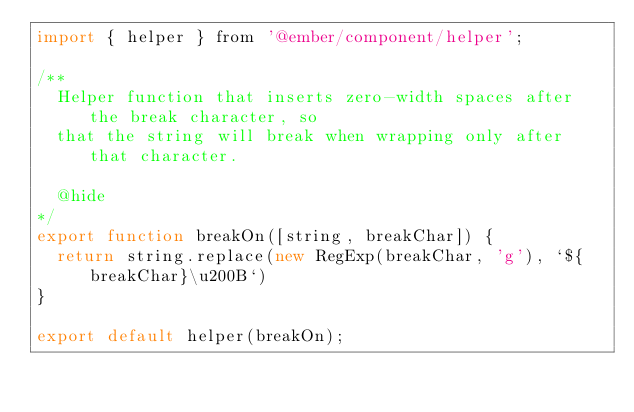<code> <loc_0><loc_0><loc_500><loc_500><_JavaScript_>import { helper } from '@ember/component/helper';

/**
  Helper function that inserts zero-width spaces after the break character, so
  that the string will break when wrapping only after that character.

  @hide
*/
export function breakOn([string, breakChar]) {
  return string.replace(new RegExp(breakChar, 'g'), `${breakChar}\u200B`)
}

export default helper(breakOn);
</code> 